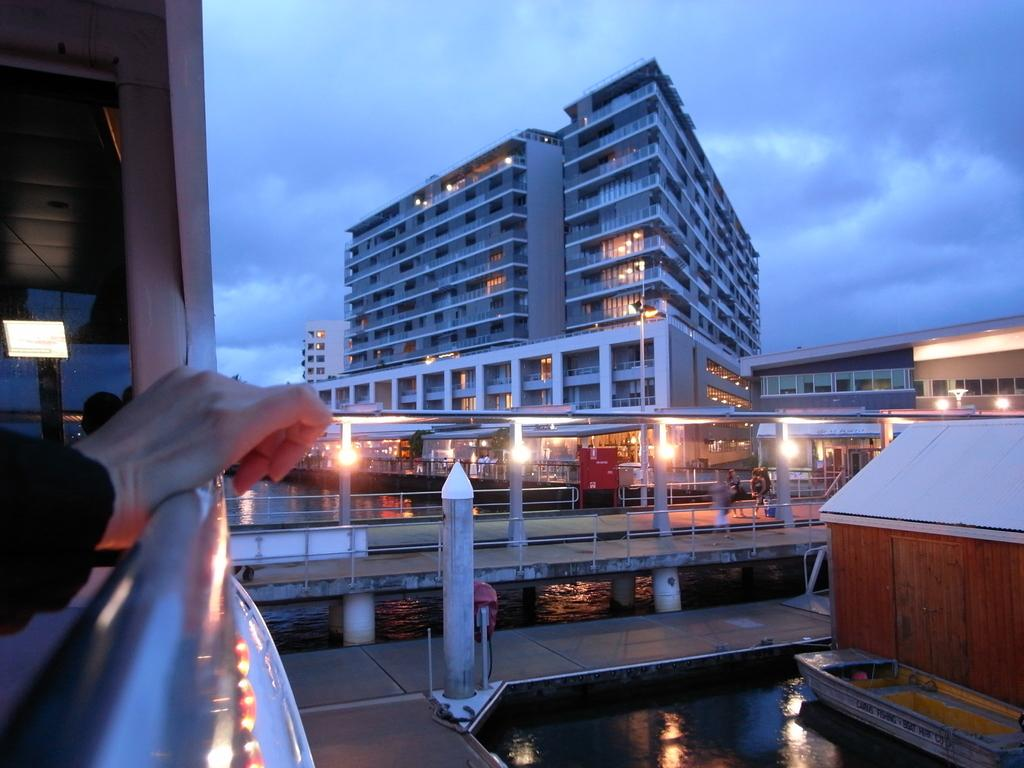What is the person's hand touching in the image? The hand of a person is touching an iron pole in the image. What is the iron pole a part of? The iron pole is part of a building. What structure can be seen in the image besides the building? There is a bridge in the image. What can be seen in the background of the image? There are multiple buildings in the background. How would you describe the weather in the image? The sky is cloudy in the image. How many waves can be seen in the ocean in the image? There is no ocean present in the image; it features a hand on an iron pole, a bridge, and multiple buildings. 